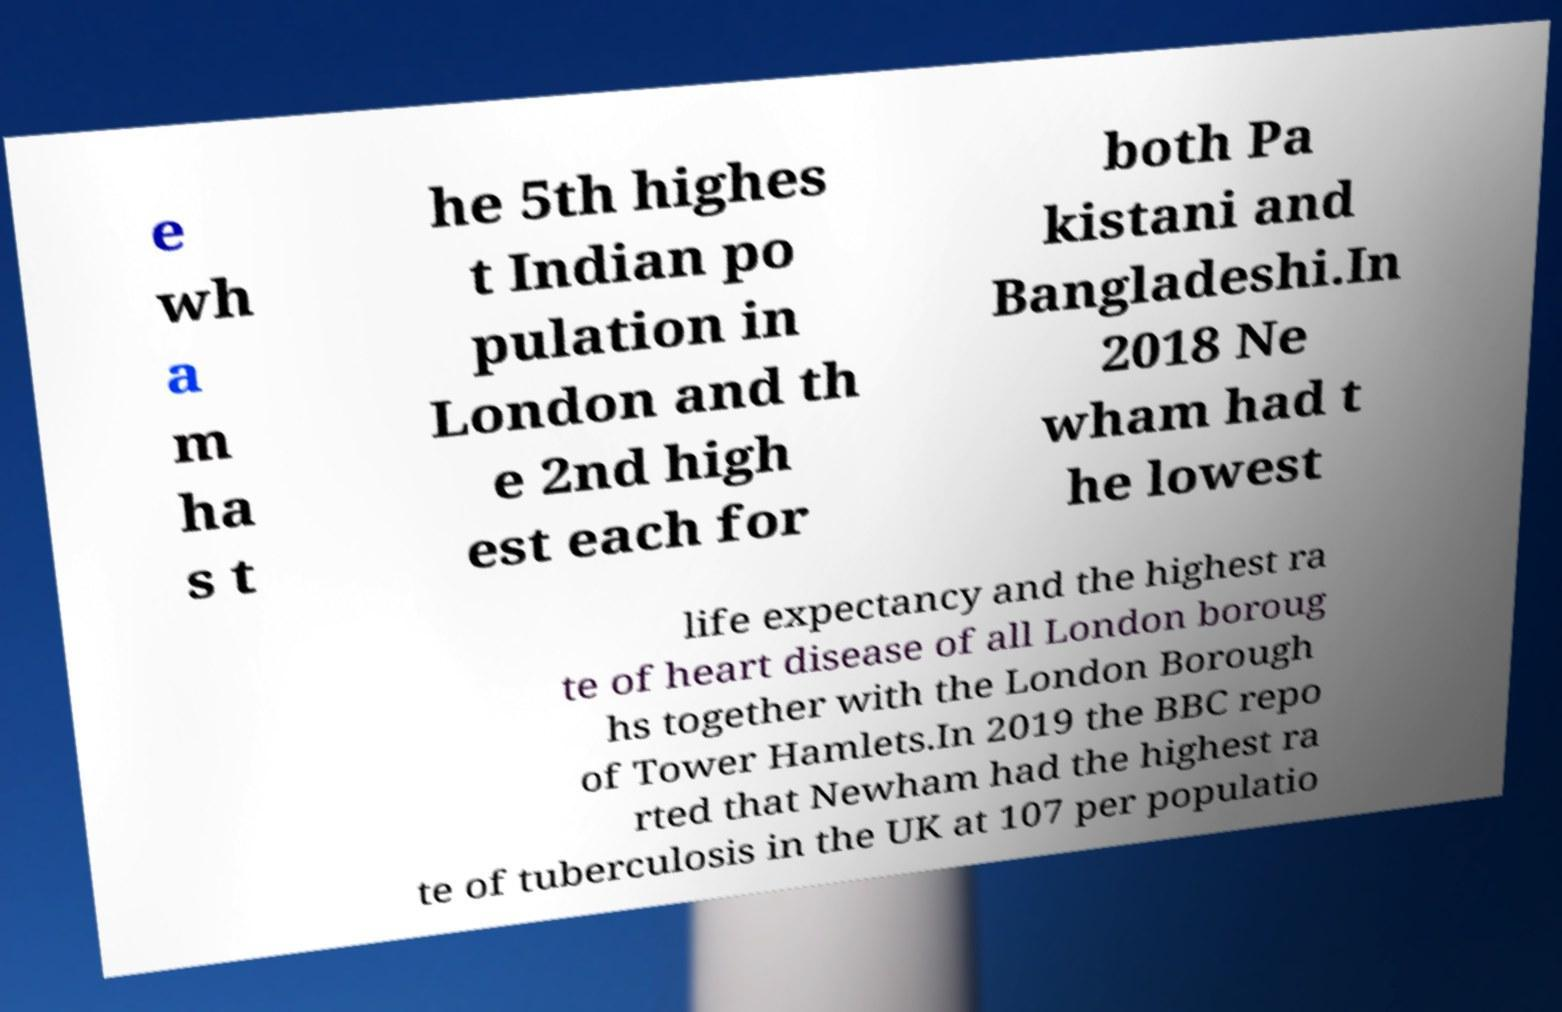Please identify and transcribe the text found in this image. e wh a m ha s t he 5th highes t Indian po pulation in London and th e 2nd high est each for both Pa kistani and Bangladeshi.In 2018 Ne wham had t he lowest life expectancy and the highest ra te of heart disease of all London boroug hs together with the London Borough of Tower Hamlets.In 2019 the BBC repo rted that Newham had the highest ra te of tuberculosis in the UK at 107 per populatio 